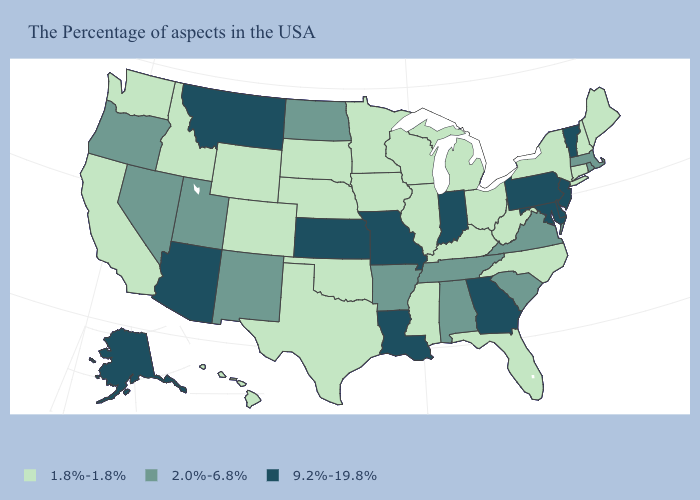Which states have the lowest value in the MidWest?
Give a very brief answer. Ohio, Michigan, Wisconsin, Illinois, Minnesota, Iowa, Nebraska, South Dakota. Name the states that have a value in the range 9.2%-19.8%?
Answer briefly. Vermont, New Jersey, Delaware, Maryland, Pennsylvania, Georgia, Indiana, Louisiana, Missouri, Kansas, Montana, Arizona, Alaska. Which states have the lowest value in the Northeast?
Give a very brief answer. Maine, New Hampshire, Connecticut, New York. What is the value of Arkansas?
Answer briefly. 2.0%-6.8%. Does the first symbol in the legend represent the smallest category?
Give a very brief answer. Yes. What is the value of Utah?
Answer briefly. 2.0%-6.8%. What is the highest value in the West ?
Short answer required. 9.2%-19.8%. Among the states that border Tennessee , which have the highest value?
Answer briefly. Georgia, Missouri. What is the value of Connecticut?
Concise answer only. 1.8%-1.8%. Name the states that have a value in the range 2.0%-6.8%?
Write a very short answer. Massachusetts, Rhode Island, Virginia, South Carolina, Alabama, Tennessee, Arkansas, North Dakota, New Mexico, Utah, Nevada, Oregon. Does Oregon have the lowest value in the West?
Concise answer only. No. Among the states that border Connecticut , does Massachusetts have the highest value?
Be succinct. Yes. Name the states that have a value in the range 1.8%-1.8%?
Answer briefly. Maine, New Hampshire, Connecticut, New York, North Carolina, West Virginia, Ohio, Florida, Michigan, Kentucky, Wisconsin, Illinois, Mississippi, Minnesota, Iowa, Nebraska, Oklahoma, Texas, South Dakota, Wyoming, Colorado, Idaho, California, Washington, Hawaii. Does the first symbol in the legend represent the smallest category?
Short answer required. Yes. What is the lowest value in states that border Massachusetts?
Answer briefly. 1.8%-1.8%. 